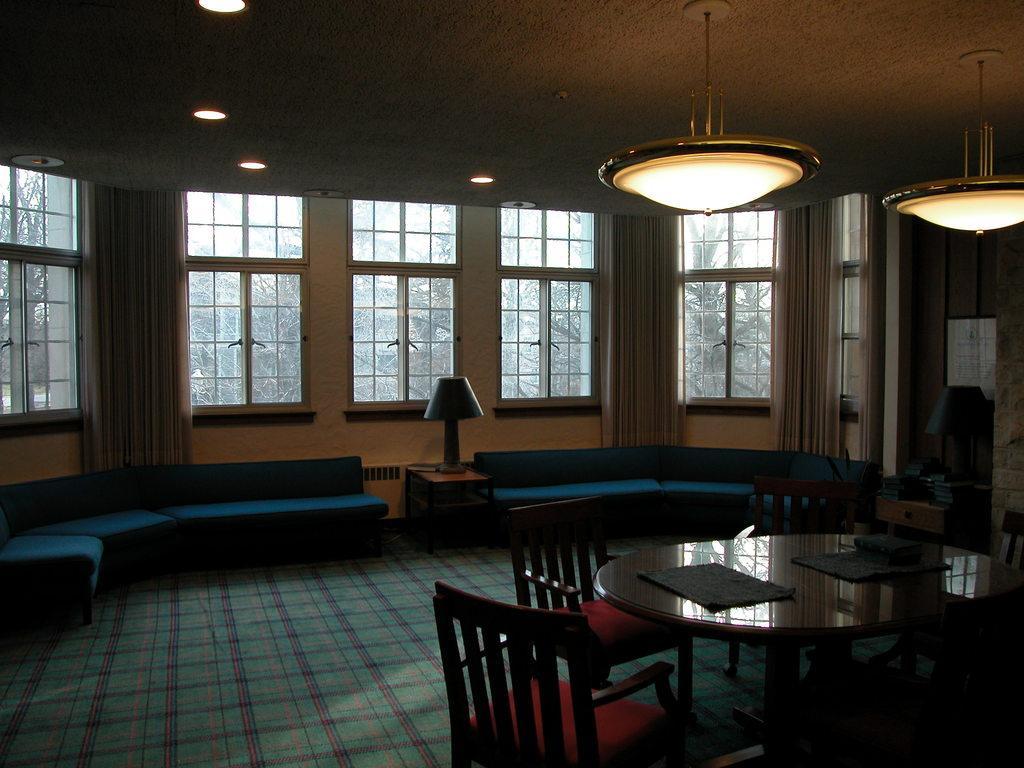In one or two sentences, can you explain what this image depicts? The image is taken in the room. In the center of the image there are sofa´s in between the sofa´s there is a stand and there a lamp placed on the stand. On the right there is a dining table. There are napkins placed on the dining table. In the background there are windows and curtains. At the top there are lights and a chandelier. 